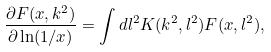<formula> <loc_0><loc_0><loc_500><loc_500>\frac { \partial F ( x , k ^ { 2 } ) } { \partial \ln ( 1 / x ) } = \int d l ^ { 2 } K ( k ^ { 2 } , l ^ { 2 } ) F ( x , l ^ { 2 } ) ,</formula> 